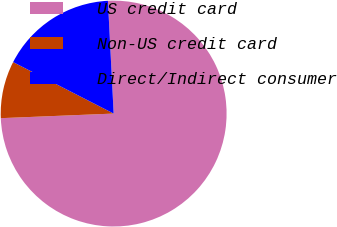<chart> <loc_0><loc_0><loc_500><loc_500><pie_chart><fcel>US credit card<fcel>Non-US credit card<fcel>Direct/Indirect consumer<nl><fcel>75.16%<fcel>8.18%<fcel>16.66%<nl></chart> 